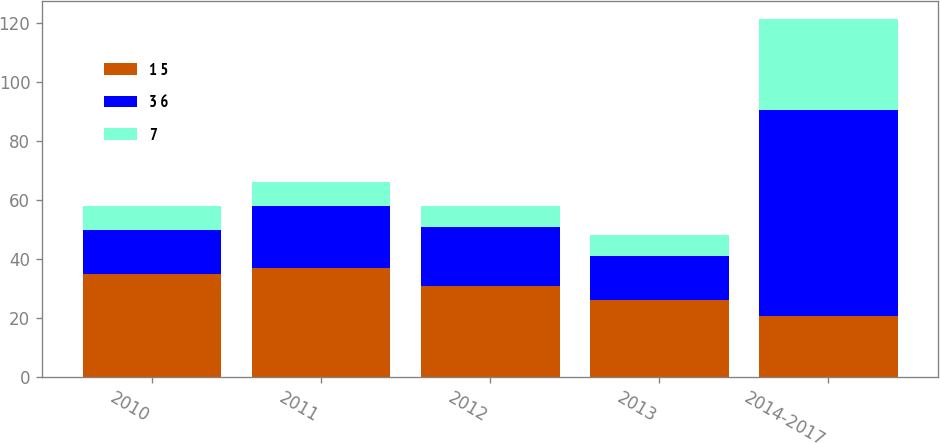<chart> <loc_0><loc_0><loc_500><loc_500><stacked_bar_chart><ecel><fcel>2010<fcel>2011<fcel>2012<fcel>2013<fcel>2014-2017<nl><fcel>1 5<fcel>35<fcel>37<fcel>31<fcel>26<fcel>20.5<nl><fcel>3 6<fcel>15<fcel>21<fcel>20<fcel>15<fcel>70<nl><fcel>7<fcel>8<fcel>8<fcel>7<fcel>7<fcel>31<nl></chart> 